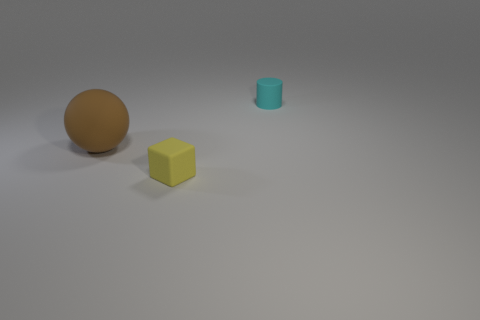Does the matte cylinder have the same color as the small rubber object in front of the cyan cylinder?
Give a very brief answer. No. The cylinder that is the same size as the matte cube is what color?
Ensure brevity in your answer.  Cyan. Is there another object that has the same shape as the cyan matte thing?
Keep it short and to the point. No. Is the number of large yellow cylinders less than the number of big balls?
Make the answer very short. Yes. There is a small thing that is in front of the tiny matte cylinder; what color is it?
Make the answer very short. Yellow. What shape is the rubber object on the right side of the tiny matte object that is in front of the tiny cyan rubber thing?
Your answer should be very brief. Cylinder. Do the yellow cube and the tiny thing that is behind the rubber ball have the same material?
Give a very brief answer. Yes. What number of matte cylinders are the same size as the brown rubber object?
Offer a very short reply. 0. Are there fewer big matte balls in front of the big brown sphere than large balls?
Provide a short and direct response. Yes. There is a brown matte object; what number of things are on the right side of it?
Offer a very short reply. 2. 